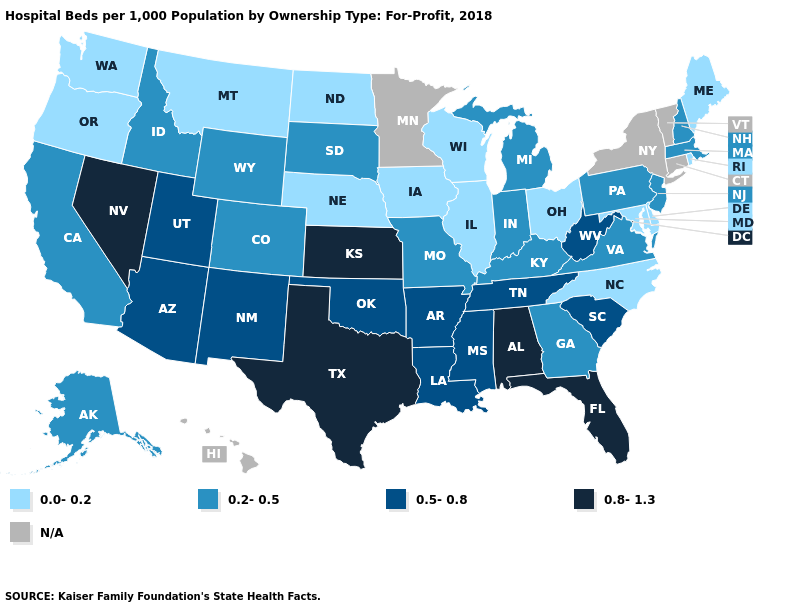What is the value of Colorado?
Short answer required. 0.2-0.5. What is the value of New Mexico?
Concise answer only. 0.5-0.8. Which states have the lowest value in the West?
Write a very short answer. Montana, Oregon, Washington. Name the states that have a value in the range 0.8-1.3?
Keep it brief. Alabama, Florida, Kansas, Nevada, Texas. Which states have the lowest value in the USA?
Give a very brief answer. Delaware, Illinois, Iowa, Maine, Maryland, Montana, Nebraska, North Carolina, North Dakota, Ohio, Oregon, Rhode Island, Washington, Wisconsin. What is the lowest value in the South?
Short answer required. 0.0-0.2. Does the map have missing data?
Give a very brief answer. Yes. Name the states that have a value in the range 0.5-0.8?
Be succinct. Arizona, Arkansas, Louisiana, Mississippi, New Mexico, Oklahoma, South Carolina, Tennessee, Utah, West Virginia. Does the map have missing data?
Write a very short answer. Yes. Is the legend a continuous bar?
Short answer required. No. Name the states that have a value in the range 0.2-0.5?
Short answer required. Alaska, California, Colorado, Georgia, Idaho, Indiana, Kentucky, Massachusetts, Michigan, Missouri, New Hampshire, New Jersey, Pennsylvania, South Dakota, Virginia, Wyoming. What is the value of West Virginia?
Answer briefly. 0.5-0.8. What is the lowest value in the USA?
Answer briefly. 0.0-0.2. What is the value of Delaware?
Quick response, please. 0.0-0.2. Name the states that have a value in the range N/A?
Short answer required. Connecticut, Hawaii, Minnesota, New York, Vermont. 